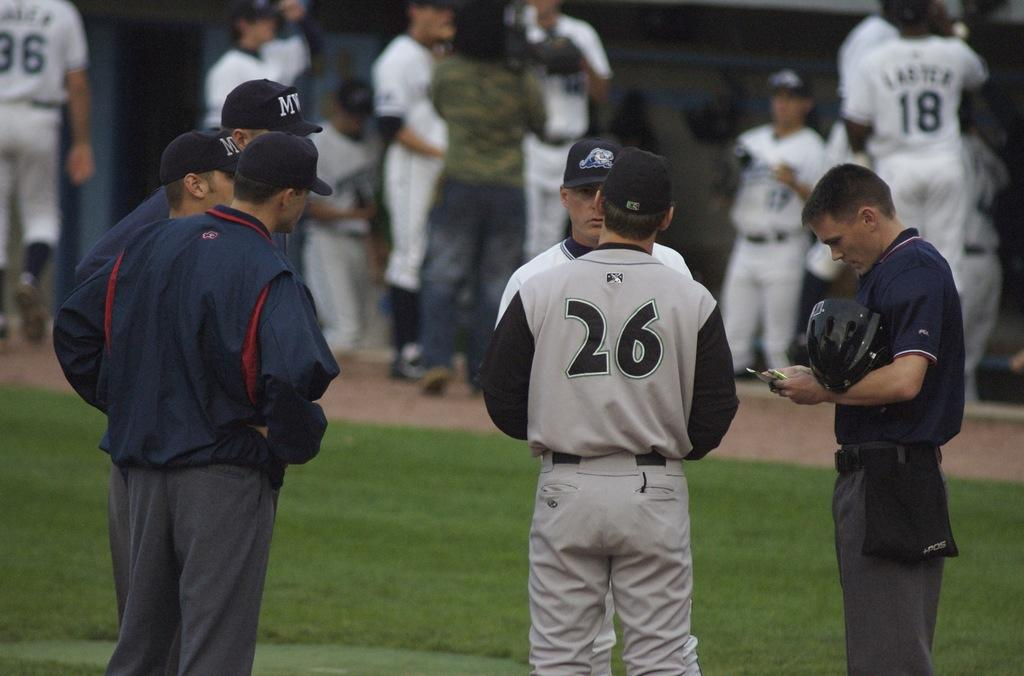<image>
Provide a brief description of the given image. Player number 26 has a discussion with an umpire on the field. 